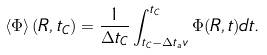Convert formula to latex. <formula><loc_0><loc_0><loc_500><loc_500>\left < \Phi \right > ( { R } , t _ { C } ) = \frac { 1 } { \Delta t _ { C } } \int _ { t _ { C } - \Delta t _ { a } v } ^ { t _ { C } } \Phi ( R , t ) d t .</formula> 